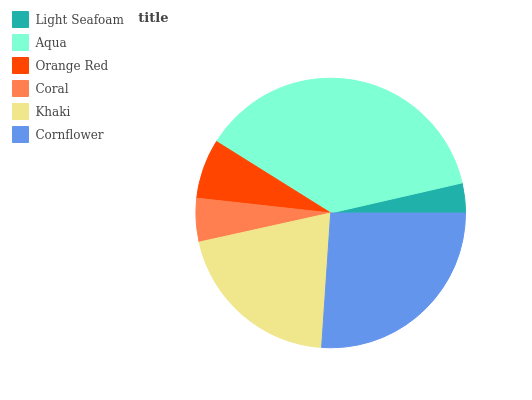Is Light Seafoam the minimum?
Answer yes or no. Yes. Is Aqua the maximum?
Answer yes or no. Yes. Is Orange Red the minimum?
Answer yes or no. No. Is Orange Red the maximum?
Answer yes or no. No. Is Aqua greater than Orange Red?
Answer yes or no. Yes. Is Orange Red less than Aqua?
Answer yes or no. Yes. Is Orange Red greater than Aqua?
Answer yes or no. No. Is Aqua less than Orange Red?
Answer yes or no. No. Is Khaki the high median?
Answer yes or no. Yes. Is Orange Red the low median?
Answer yes or no. Yes. Is Cornflower the high median?
Answer yes or no. No. Is Coral the low median?
Answer yes or no. No. 